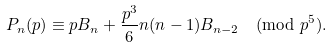<formula> <loc_0><loc_0><loc_500><loc_500>P _ { n } ( p ) \equiv p B _ { n } + \frac { p ^ { 3 } } { 6 } n ( n - 1 ) B _ { n - 2 } \pmod { p ^ { 5 } } .</formula> 